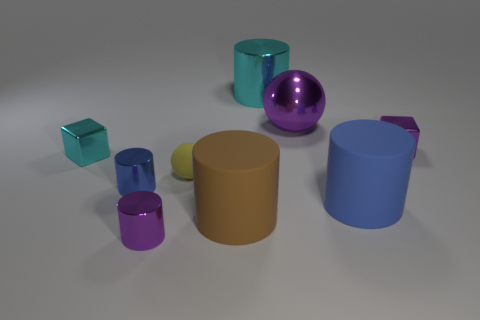There is a metal block that is to the right of the small purple metal object in front of the small blue cylinder; how big is it?
Your response must be concise. Small. Do the big ball and the matte object that is to the right of the large brown rubber thing have the same color?
Offer a terse response. No. Is there a matte ball of the same size as the purple cylinder?
Make the answer very short. Yes. How big is the rubber cylinder to the left of the large cyan shiny thing?
Offer a terse response. Large. Are there any tiny blocks behind the cylinder that is behind the small yellow object?
Provide a short and direct response. No. How many other things are the same shape as the large brown matte thing?
Your response must be concise. 4. Is the small yellow rubber thing the same shape as the blue metal object?
Offer a terse response. No. What is the color of the metallic object that is both on the left side of the big purple metal thing and behind the purple metal block?
Offer a terse response. Cyan. What size is the shiny cube that is the same color as the large sphere?
Offer a terse response. Small. How many small things are purple blocks or shiny cubes?
Give a very brief answer. 2. 